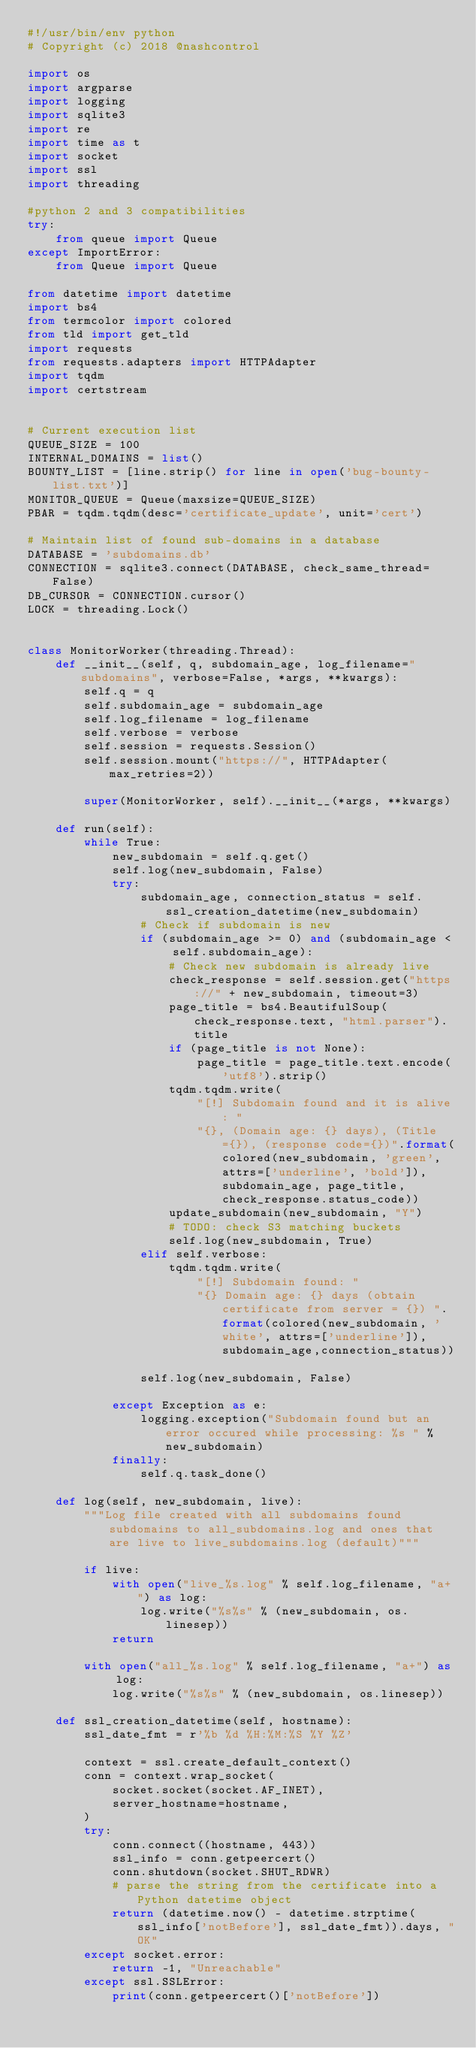Convert code to text. <code><loc_0><loc_0><loc_500><loc_500><_Python_>#!/usr/bin/env python
# Copyright (c) 2018 @nashcontrol

import os
import argparse
import logging
import sqlite3
import re
import time as t
import socket
import ssl
import threading

#python 2 and 3 compatibilities
try:
    from queue import Queue
except ImportError:
    from Queue import Queue

from datetime import datetime
import bs4
from termcolor import colored
from tld import get_tld
import requests
from requests.adapters import HTTPAdapter
import tqdm
import certstream


# Current execution list
QUEUE_SIZE = 100
INTERNAL_DOMAINS = list()
BOUNTY_LIST = [line.strip() for line in open('bug-bounty-list.txt')]
MONITOR_QUEUE = Queue(maxsize=QUEUE_SIZE)
PBAR = tqdm.tqdm(desc='certificate_update', unit='cert')

# Maintain list of found sub-domains in a database
DATABASE = 'subdomains.db'
CONNECTION = sqlite3.connect(DATABASE, check_same_thread=False)
DB_CURSOR = CONNECTION.cursor()
LOCK = threading.Lock()


class MonitorWorker(threading.Thread):
    def __init__(self, q, subdomain_age, log_filename="subdomains", verbose=False, *args, **kwargs):
        self.q = q
        self.subdomain_age = subdomain_age
        self.log_filename = log_filename
        self.verbose = verbose
        self.session = requests.Session()
        self.session.mount("https://", HTTPAdapter(max_retries=2))

        super(MonitorWorker, self).__init__(*args, **kwargs)

    def run(self):
        while True:
            new_subdomain = self.q.get()
            self.log(new_subdomain, False)
            try:
                subdomain_age, connection_status = self.ssl_creation_datetime(new_subdomain)
                # Check if subdomain is new
                if (subdomain_age >= 0) and (subdomain_age < self.subdomain_age):              
                    # Check new subdomain is already live
                    check_response = self.session.get("https://" + new_subdomain, timeout=3)
                    page_title = bs4.BeautifulSoup(check_response.text, "html.parser").title
                    if (page_title is not None):
                        page_title = page_title.text.encode('utf8').strip()
                    tqdm.tqdm.write(
                        "[!] Subdomain found and it is alive: "
                        "{}, (Domain age: {} days), (Title={}), (response code={})".format(colored(new_subdomain, 'green', attrs=['underline', 'bold']), subdomain_age, page_title, check_response.status_code))
                    update_subdomain(new_subdomain, "Y")
                    # TODO: check S3 matching buckets
                    self.log(new_subdomain, True)
                elif self.verbose:
                    tqdm.tqdm.write(
                        "[!] Subdomain found: "
                        "{} Domain age: {} days (obtain certificate from server = {}) ".format(colored(new_subdomain, 'white', attrs=['underline']),subdomain_age,connection_status))

                self.log(new_subdomain, False)

            except Exception as e:
                logging.exception("Subdomain found but an error occured while processing: %s " % new_subdomain)
            finally:
                self.q.task_done()

    def log(self, new_subdomain, live):
        """Log file created with all subdomains found subdomains to all_subdomains.log and ones that are live to live_subdomains.log (default)"""

        if live:
            with open("live_%s.log" % self.log_filename, "a+") as log:
                log.write("%s%s" % (new_subdomain, os.linesep))
            return

        with open("all_%s.log" % self.log_filename, "a+") as log:
            log.write("%s%s" % (new_subdomain, os.linesep))

    def ssl_creation_datetime(self, hostname):
        ssl_date_fmt = r'%b %d %H:%M:%S %Y %Z'

        context = ssl.create_default_context()
        conn = context.wrap_socket(
            socket.socket(socket.AF_INET),
            server_hostname=hostname,
        )
        try:
            conn.connect((hostname, 443))
            ssl_info = conn.getpeercert()
            conn.shutdown(socket.SHUT_RDWR)
            # parse the string from the certificate into a Python datetime object
            return (datetime.now() - datetime.strptime(ssl_info['notBefore'], ssl_date_fmt)).days, "OK"
        except socket.error:
            return -1, "Unreachable"
        except ssl.SSLError:
            print(conn.getpeercert()['notBefore'])</code> 